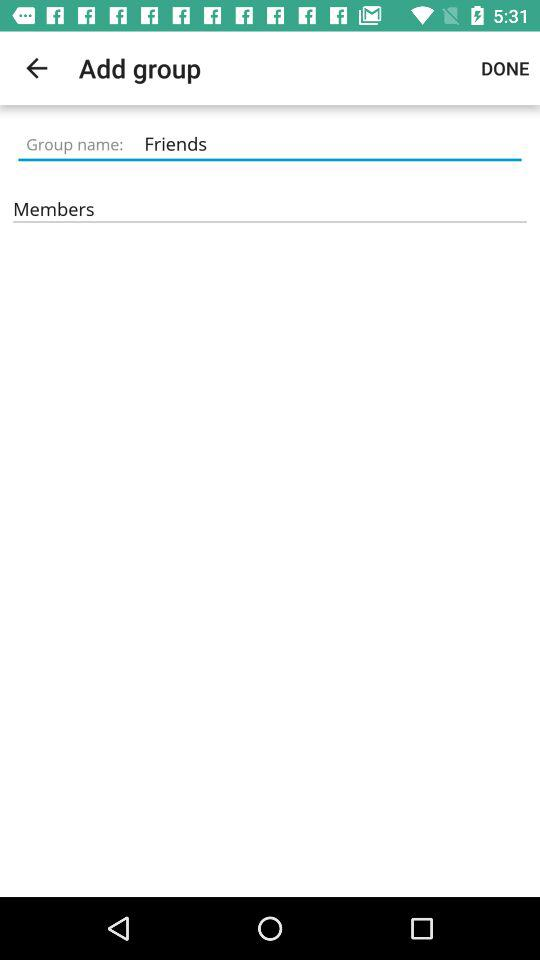What is the group name? The group name is "Friends". 